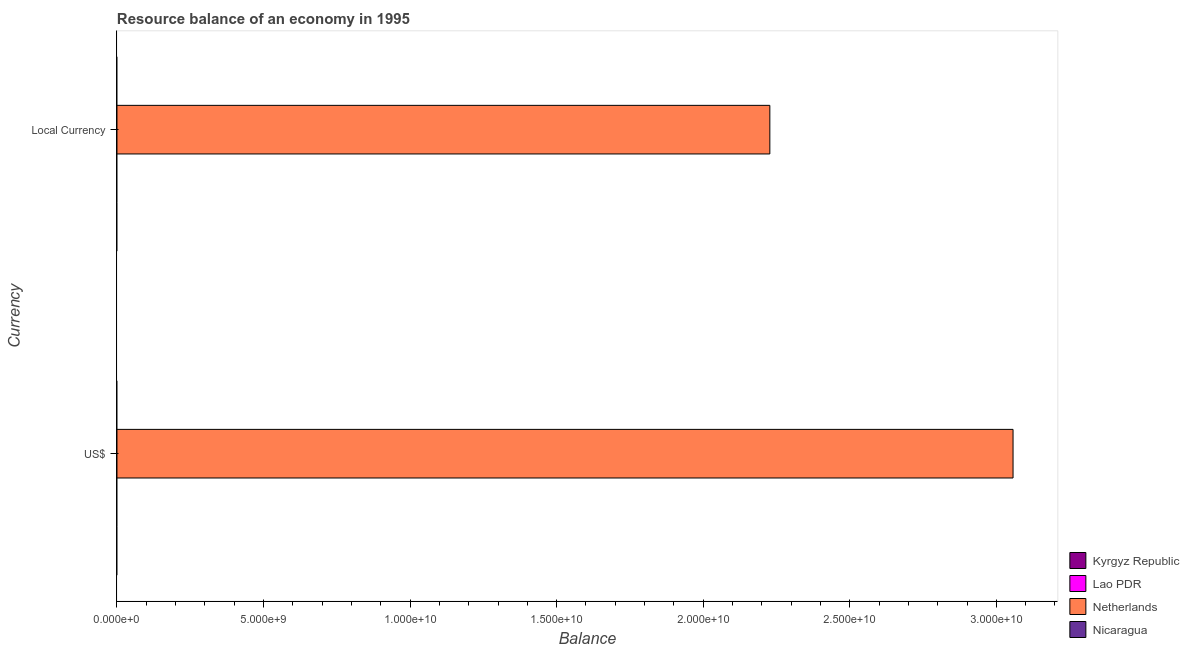Are the number of bars per tick equal to the number of legend labels?
Ensure brevity in your answer.  No. How many bars are there on the 1st tick from the top?
Ensure brevity in your answer.  1. What is the label of the 2nd group of bars from the top?
Provide a succinct answer. US$. What is the resource balance in us$ in Netherlands?
Your answer should be very brief. 3.06e+1. Across all countries, what is the maximum resource balance in constant us$?
Offer a terse response. 2.23e+1. Across all countries, what is the minimum resource balance in constant us$?
Give a very brief answer. 0. In which country was the resource balance in us$ maximum?
Make the answer very short. Netherlands. What is the total resource balance in constant us$ in the graph?
Your response must be concise. 2.23e+1. What is the difference between the resource balance in us$ in Nicaragua and the resource balance in constant us$ in Kyrgyz Republic?
Your answer should be compact. 0. What is the average resource balance in constant us$ per country?
Make the answer very short. 5.57e+09. What is the difference between the resource balance in us$ and resource balance in constant us$ in Netherlands?
Make the answer very short. 8.30e+09. In how many countries, is the resource balance in us$ greater than the average resource balance in us$ taken over all countries?
Provide a succinct answer. 1. How many bars are there?
Provide a short and direct response. 2. How many countries are there in the graph?
Your answer should be very brief. 4. Are the values on the major ticks of X-axis written in scientific E-notation?
Provide a short and direct response. Yes. Does the graph contain any zero values?
Your answer should be very brief. Yes. Does the graph contain grids?
Keep it short and to the point. No. How many legend labels are there?
Provide a succinct answer. 4. What is the title of the graph?
Ensure brevity in your answer.  Resource balance of an economy in 1995. What is the label or title of the X-axis?
Your answer should be compact. Balance. What is the label or title of the Y-axis?
Keep it short and to the point. Currency. What is the Balance in Kyrgyz Republic in US$?
Your answer should be compact. 0. What is the Balance of Lao PDR in US$?
Offer a terse response. 0. What is the Balance in Netherlands in US$?
Provide a short and direct response. 3.06e+1. What is the Balance of Kyrgyz Republic in Local Currency?
Keep it short and to the point. 0. What is the Balance in Netherlands in Local Currency?
Provide a succinct answer. 2.23e+1. What is the Balance of Nicaragua in Local Currency?
Your answer should be compact. 0. Across all Currency, what is the maximum Balance in Netherlands?
Keep it short and to the point. 3.06e+1. Across all Currency, what is the minimum Balance in Netherlands?
Your response must be concise. 2.23e+1. What is the total Balance in Kyrgyz Republic in the graph?
Give a very brief answer. 0. What is the total Balance of Lao PDR in the graph?
Your response must be concise. 0. What is the total Balance in Netherlands in the graph?
Provide a short and direct response. 5.28e+1. What is the total Balance in Nicaragua in the graph?
Your answer should be compact. 0. What is the difference between the Balance in Netherlands in US$ and that in Local Currency?
Ensure brevity in your answer.  8.30e+09. What is the average Balance of Netherlands per Currency?
Your answer should be very brief. 2.64e+1. What is the ratio of the Balance of Netherlands in US$ to that in Local Currency?
Your response must be concise. 1.37. What is the difference between the highest and the second highest Balance in Netherlands?
Provide a short and direct response. 8.30e+09. What is the difference between the highest and the lowest Balance in Netherlands?
Your answer should be compact. 8.30e+09. 